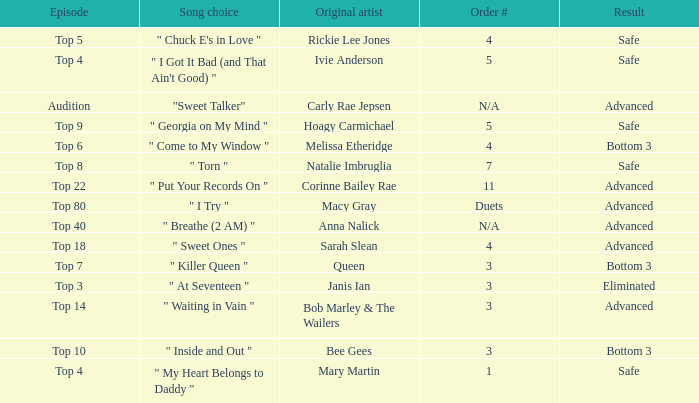What's the original artist of the song performed in the top 3 episode? Janis Ian. 